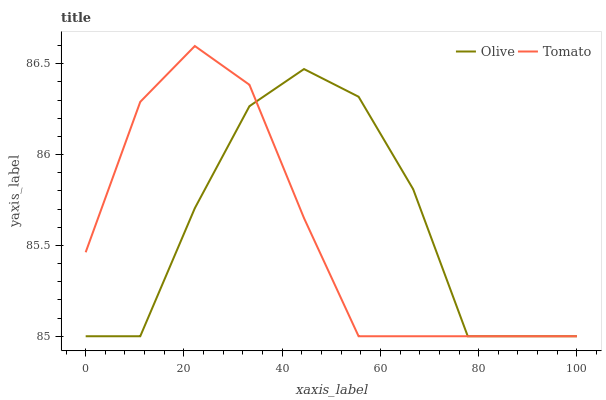Does Tomato have the minimum area under the curve?
Answer yes or no. Yes. Does Olive have the maximum area under the curve?
Answer yes or no. Yes. Does Tomato have the maximum area under the curve?
Answer yes or no. No. Is Tomato the smoothest?
Answer yes or no. Yes. Is Olive the roughest?
Answer yes or no. Yes. Is Tomato the roughest?
Answer yes or no. No. Does Olive have the lowest value?
Answer yes or no. Yes. Does Tomato have the highest value?
Answer yes or no. Yes. Does Olive intersect Tomato?
Answer yes or no. Yes. Is Olive less than Tomato?
Answer yes or no. No. Is Olive greater than Tomato?
Answer yes or no. No. 